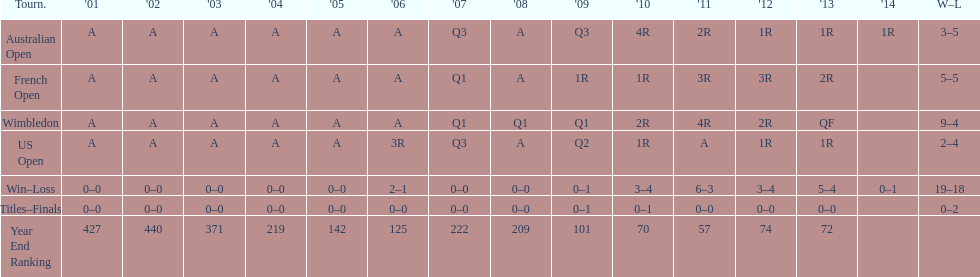What is the difference in wins between wimbledon and the us open for this player? 7. 